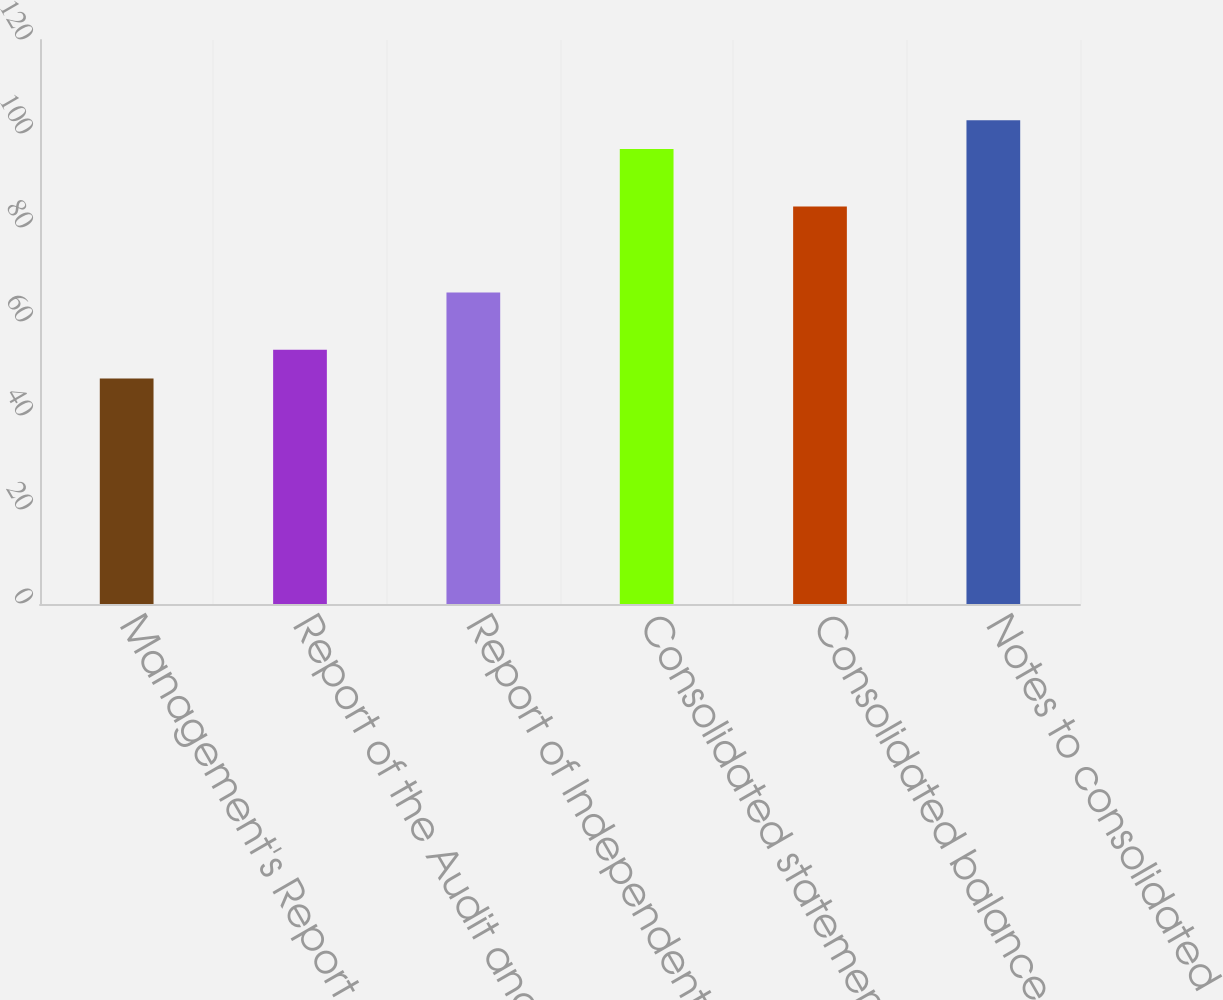Convert chart. <chart><loc_0><loc_0><loc_500><loc_500><bar_chart><fcel>Management's Report on<fcel>Report of the Audit and<fcel>Report of Independent<fcel>Consolidated statements of<fcel>Consolidated balance sheets<fcel>Notes to consolidated<nl><fcel>48<fcel>54.1<fcel>66.3<fcel>96.8<fcel>84.6<fcel>102.9<nl></chart> 